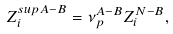<formula> <loc_0><loc_0><loc_500><loc_500>Z _ { i } ^ { s u p A - B } = \nu _ { p } ^ { A - B } Z _ { i } ^ { N - B } ,</formula> 